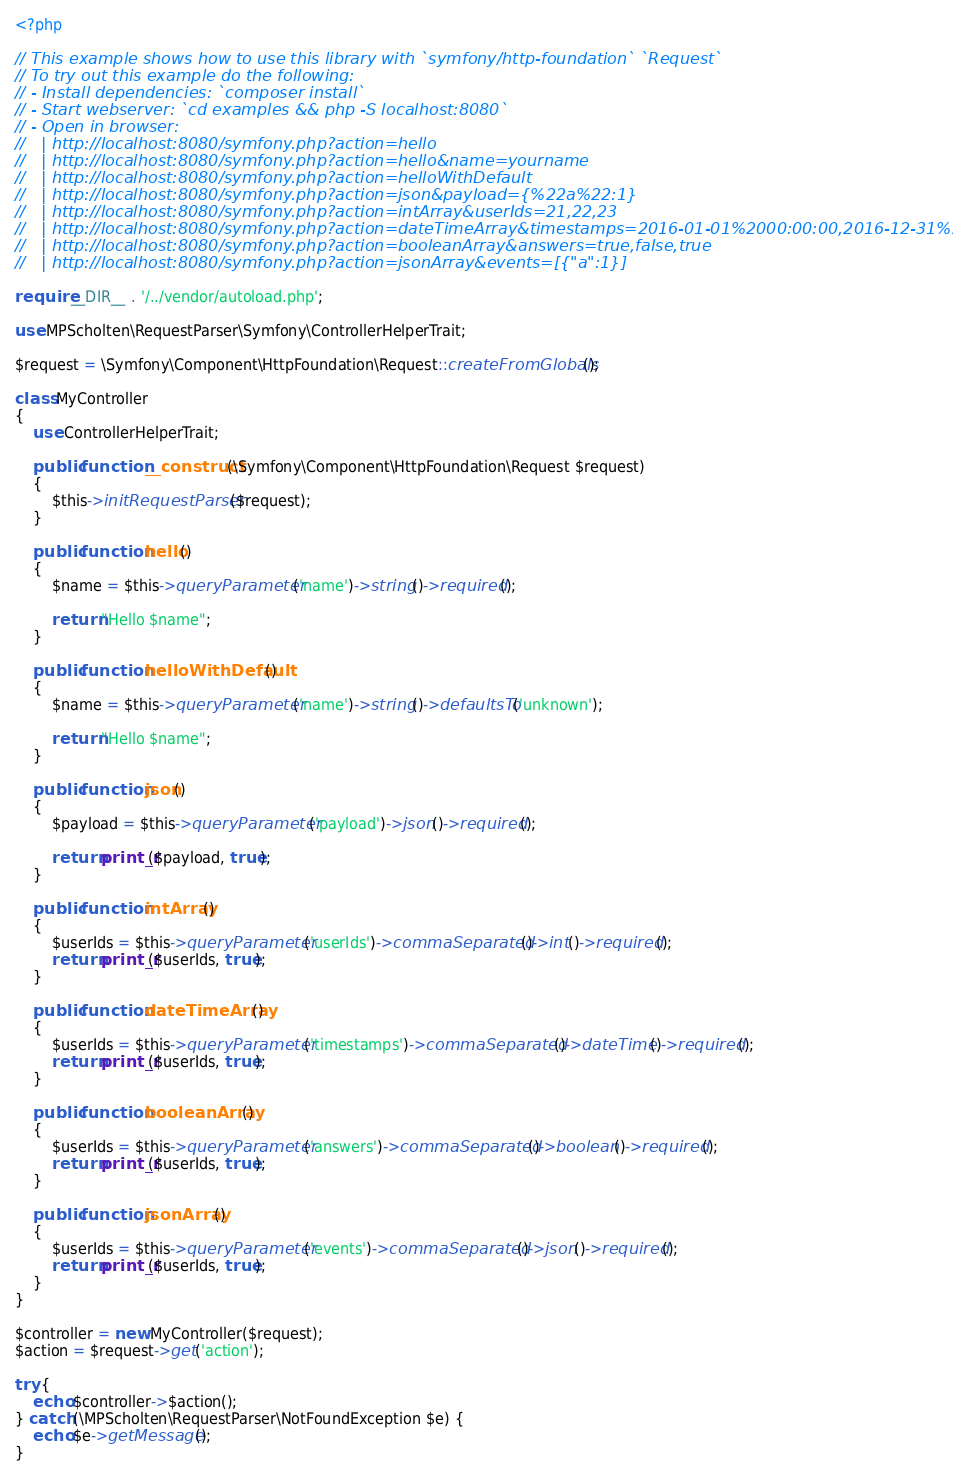<code> <loc_0><loc_0><loc_500><loc_500><_PHP_><?php

// This example shows how to use this library with `symfony/http-foundation` `Request`
// To try out this example do the following:
// - Install dependencies: `composer install`
// - Start webserver: `cd examples && php -S localhost:8080`
// - Open in browser:
//   | http://localhost:8080/symfony.php?action=hello
//   | http://localhost:8080/symfony.php?action=hello&name=yourname
//   | http://localhost:8080/symfony.php?action=helloWithDefault
//   | http://localhost:8080/symfony.php?action=json&payload={%22a%22:1}
//   | http://localhost:8080/symfony.php?action=intArray&userIds=21,22,23
//   | http://localhost:8080/symfony.php?action=dateTimeArray&timestamps=2016-01-01%2000:00:00,2016-12-31%2023:59:59
//   | http://localhost:8080/symfony.php?action=booleanArray&answers=true,false,true
//   | http://localhost:8080/symfony.php?action=jsonArray&events=[{"a":1}]

require __DIR__ . '/../vendor/autoload.php';

use MPScholten\RequestParser\Symfony\ControllerHelperTrait;

$request = \Symfony\Component\HttpFoundation\Request::createFromGlobals();

class MyController
{
    use ControllerHelperTrait;

    public function __construct(\Symfony\Component\HttpFoundation\Request $request)
    {
        $this->initRequestParser($request);
    }

    public function hello()
    {
        $name = $this->queryParameter('name')->string()->required();

        return "Hello $name";
    }

    public function helloWithDefault()
    {
        $name = $this->queryParameter('name')->string()->defaultsTo('unknown');

        return "Hello $name";
    }

    public function json()
    {
        $payload = $this->queryParameter('payload')->json()->required();

        return print_r($payload, true);
    }

    public function intArray()
    {
        $userIds = $this->queryParameter('userIds')->commaSeparated()->int()->required();
        return print_r($userIds, true);
    }

    public function dateTimeArray()
    {
        $userIds = $this->queryParameter('timestamps')->commaSeparated()->dateTime()->required();
        return print_r($userIds, true);
    }

    public function booleanArray()
    {
        $userIds = $this->queryParameter('answers')->commaSeparated()->boolean()->required();
        return print_r($userIds, true);
    }

    public function jsonArray()
    {
        $userIds = $this->queryParameter('events')->commaSeparated()->json()->required();
        return print_r($userIds, true);
    }
}

$controller = new MyController($request);
$action = $request->get('action');

try {
    echo $controller->$action();
} catch (\MPScholten\RequestParser\NotFoundException $e) {
    echo $e->getMessage();
}
</code> 